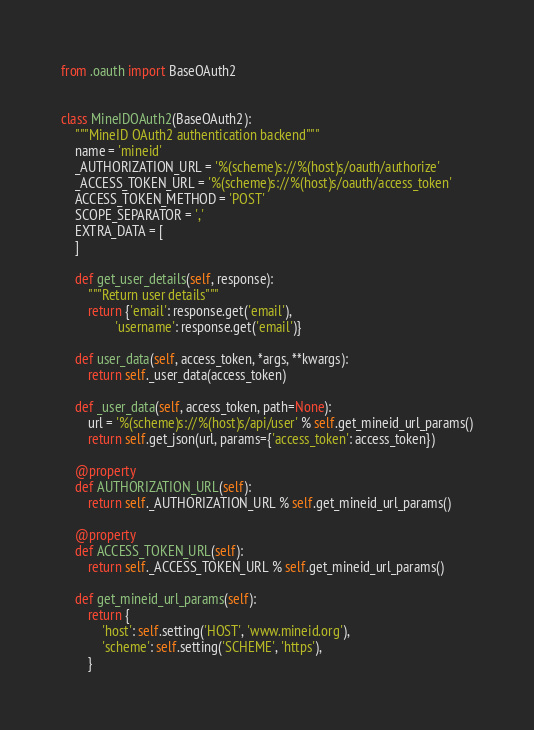<code> <loc_0><loc_0><loc_500><loc_500><_Python_>from .oauth import BaseOAuth2


class MineIDOAuth2(BaseOAuth2):
    """MineID OAuth2 authentication backend"""
    name = 'mineid'
    _AUTHORIZATION_URL = '%(scheme)s://%(host)s/oauth/authorize'
    _ACCESS_TOKEN_URL = '%(scheme)s://%(host)s/oauth/access_token'
    ACCESS_TOKEN_METHOD = 'POST'
    SCOPE_SEPARATOR = ','
    EXTRA_DATA = [
    ]

    def get_user_details(self, response):
        """Return user details"""
        return {'email': response.get('email'),
                'username': response.get('email')}

    def user_data(self, access_token, *args, **kwargs):
        return self._user_data(access_token)

    def _user_data(self, access_token, path=None):
        url = '%(scheme)s://%(host)s/api/user' % self.get_mineid_url_params()
        return self.get_json(url, params={'access_token': access_token})

    @property
    def AUTHORIZATION_URL(self):
        return self._AUTHORIZATION_URL % self.get_mineid_url_params()

    @property
    def ACCESS_TOKEN_URL(self):
        return self._ACCESS_TOKEN_URL % self.get_mineid_url_params()

    def get_mineid_url_params(self):
        return {
            'host': self.setting('HOST', 'www.mineid.org'),
            'scheme': self.setting('SCHEME', 'https'),
        }
</code> 